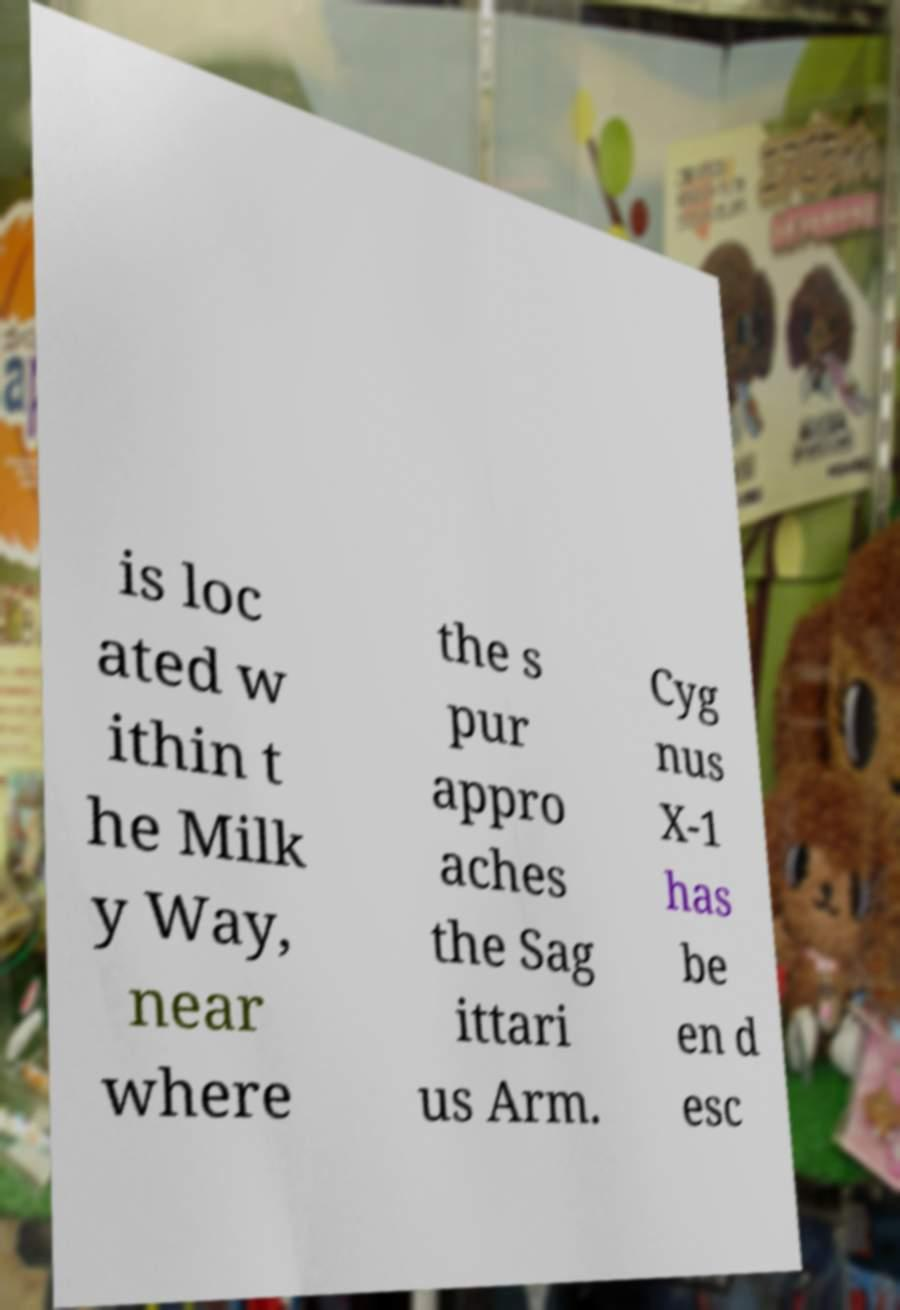Can you read and provide the text displayed in the image?This photo seems to have some interesting text. Can you extract and type it out for me? is loc ated w ithin t he Milk y Way, near where the s pur appro aches the Sag ittari us Arm. Cyg nus X-1 has be en d esc 